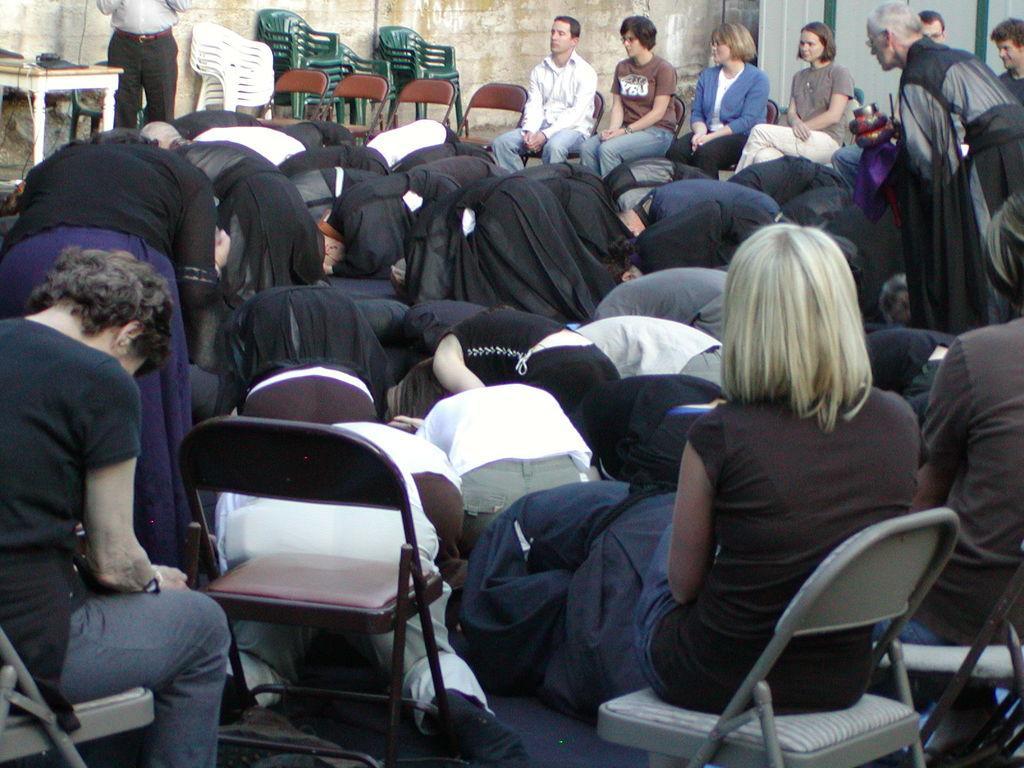In one or two sentences, can you explain what this image depicts? In this picture there are group of people where few among them are sitting in chairs and the remaining are sitting on their knees and there are some other objects in the background. 